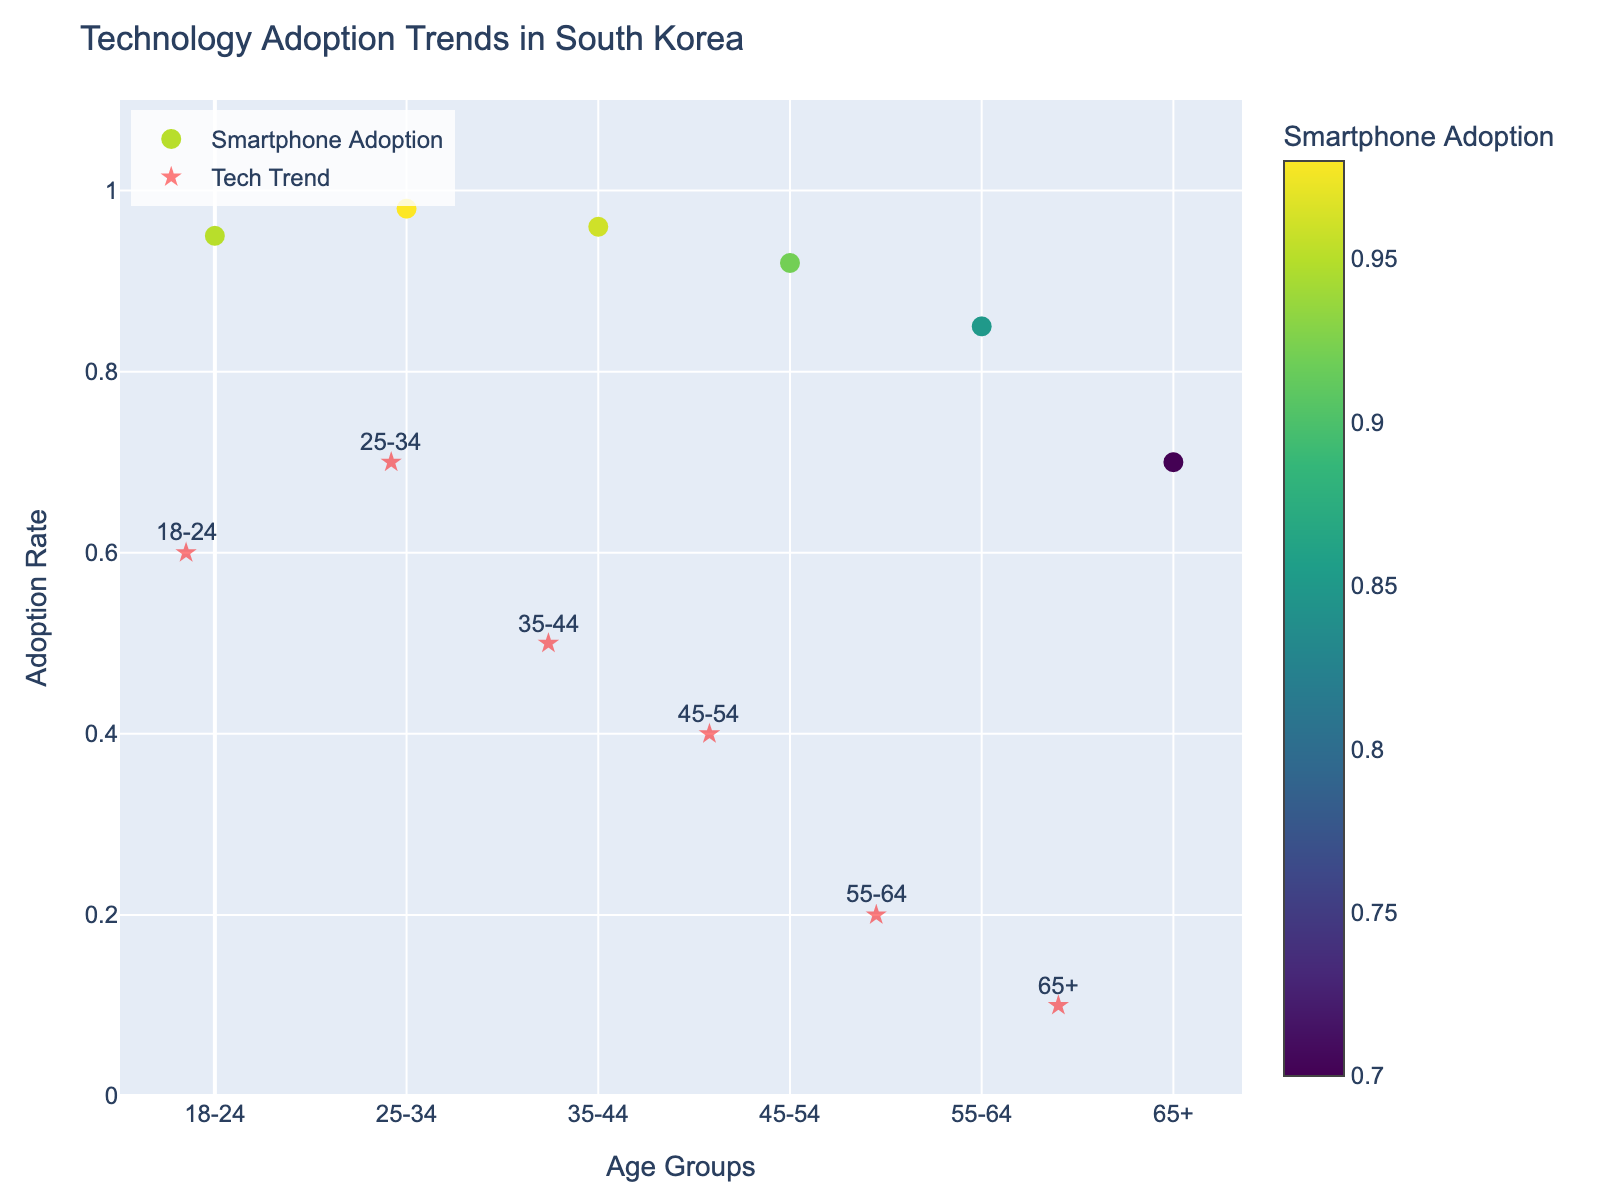What is the title of the plot? The title is located at the top of the plot, and it is usually given in a larger and bold font to stand out.
Answer: Technology Adoption Trends in South Korea What is represented by the color scale? Look for the color bar on the side of the plot. It has a title indicating what the color represents.
Answer: Smartphone Adoption Which age group has the highest smartphone adoption rate? Identify the highest point on the y-axis and read the corresponding age group from the annotations.
Answer: 25-34 How does the adoption rate of mobile payments compare between the age groups 18-24 and 65+? Check the length of the red arrows representing the mobile payment adoption rate from the smartphone adoption level.
Answer: 18-24 has a significantly higher rate than 65+ Which age group shows the smallest use of cloud services? Identify the shortest red arrows pointing in the y-direction. Compare these for all age groups.
Answer: 65+ What is the average smartphone adoption rate across all age groups? Add all adoption rates: 0.95, 0.98, 0.96, 0.92, 0.85, 0.70 and divide by the number of groups (6).
Answer: (0.95 + 0.98 + 0.96 + 0.92 + 0.85 + 0.70) / 6 = 0.8933 How does cloud services usage change from age group 35-44 to 45-54? Look at the y-end of the arrow for each of these groups and compare the length from the base point.
Answer: It decreases Which age group shows the largest difference between smartphone adoption and mobile payment usage? Look at the length of the horizontal component of the red quiver arrows.
Answer: 18-24 Which two age groups exhibit equal usage for mobile payments and cloud services? Assess the end points of the arrows to find age groups where mobile payment and cloud services values are identical. Check the respective x and y values for each endpoint.
Answer: None At what smartphone adoption rate do the length of the red quiver arrows seem to have the most variability? Identify the y-values having variable quiver arrow lengths by glancing through the lengths for different age groups.
Answer: Around 0.95 How much more prevalent is smartphone adoption in the 25-34 age group compared to the 65+ age group? Subtract the smartphone adoption rate of the 65+ age group from the 25-34 age group.
Answer: 0.98 - 0.70 = 0.28 